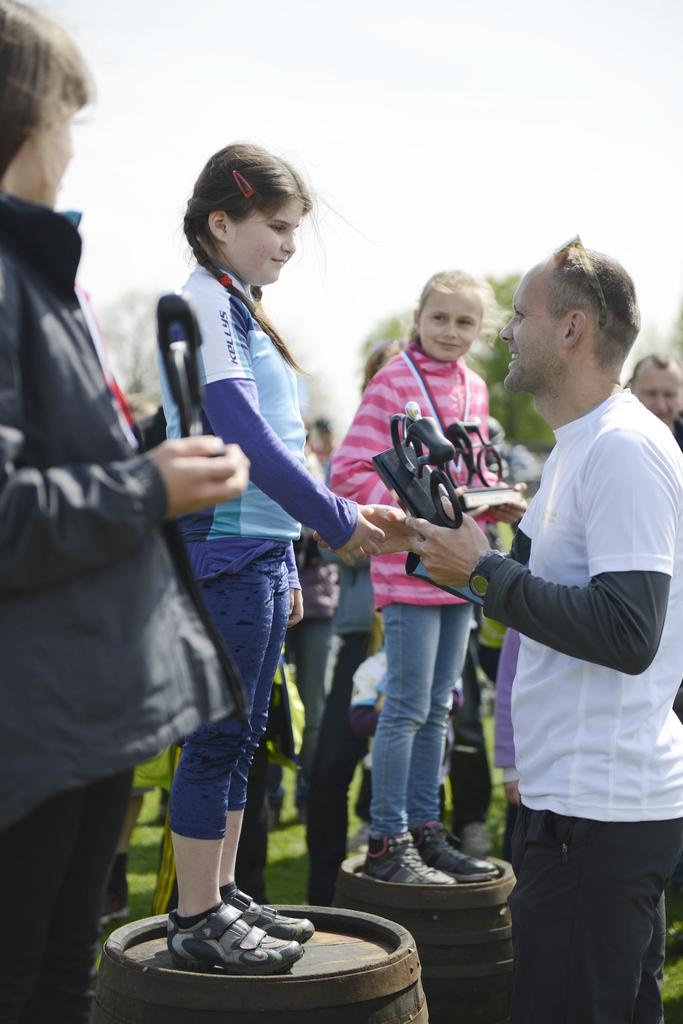How many people are in the image? There are people in the image, but the exact number is not specified. What are some people doing in the image? Some people are standing on barrels in the image. What can be seen in the background of the image? The sky is visible in the background of the image. What is the man holding in his hand? The man is holding something in his hand, but the specific object is not described. How many worms can be seen crawling on the cart in the image? There is no cart or worms present in the image. What is the slope of the hill in the image? There is no hill or slope present in the image. 